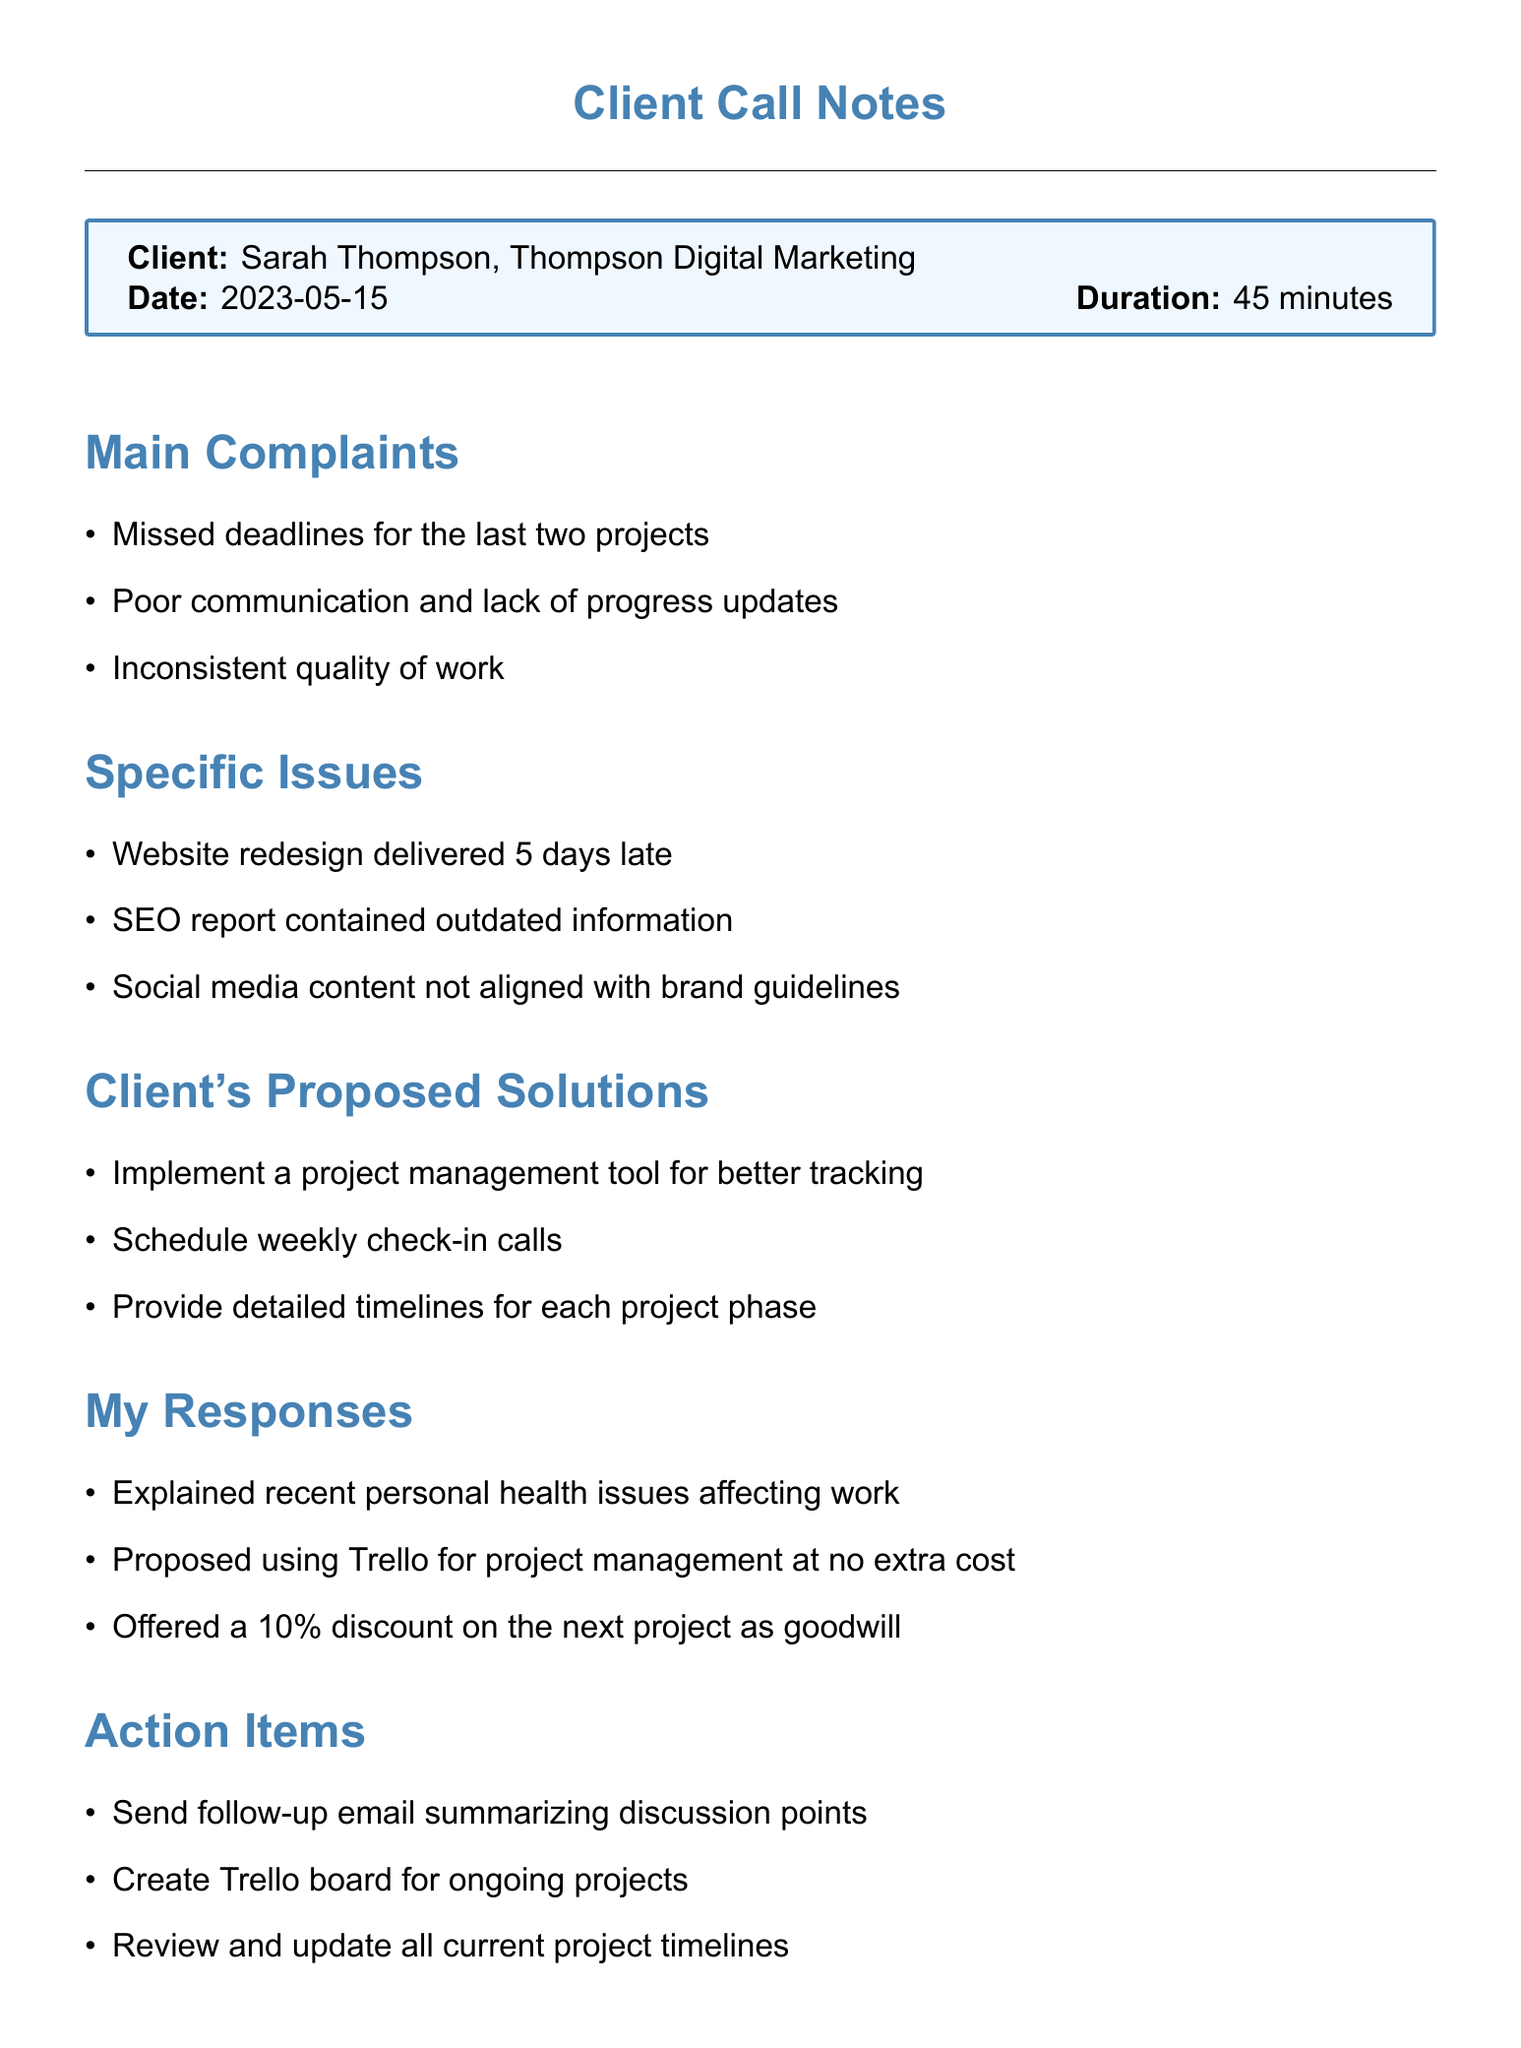What is the client's name? The client's name is mentioned at the beginning of the document.
Answer: Sarah Thompson What is the duration of the call? The duration of the call is specified in the client details section.
Answer: 45 minutes What was delivered 5 days late? This detail is included in the specific issues section of the document.
Answer: Website redesign What discount did I offer on the next project? The discount offered is stated in my responses.
Answer: 10% What is one proposed solution for communication improvement? This is listed under the client's proposed solutions.
Answer: Schedule weekly check-in calls How many main complaints did the client voice? The count of main complaints is outlined in the main complaints section.
Answer: Three What is the date of the call? This information is clearly provided in the client details section.
Answer: 2023-05-15 What project management tool did I propose to use? The tool is mentioned in my responses to the client's complaints.
Answer: Trello What is a personal note I made about the client's attitude? This reflects my impression of the client from the personal notes section.
Answer: Frustrated but willing to continue working together 